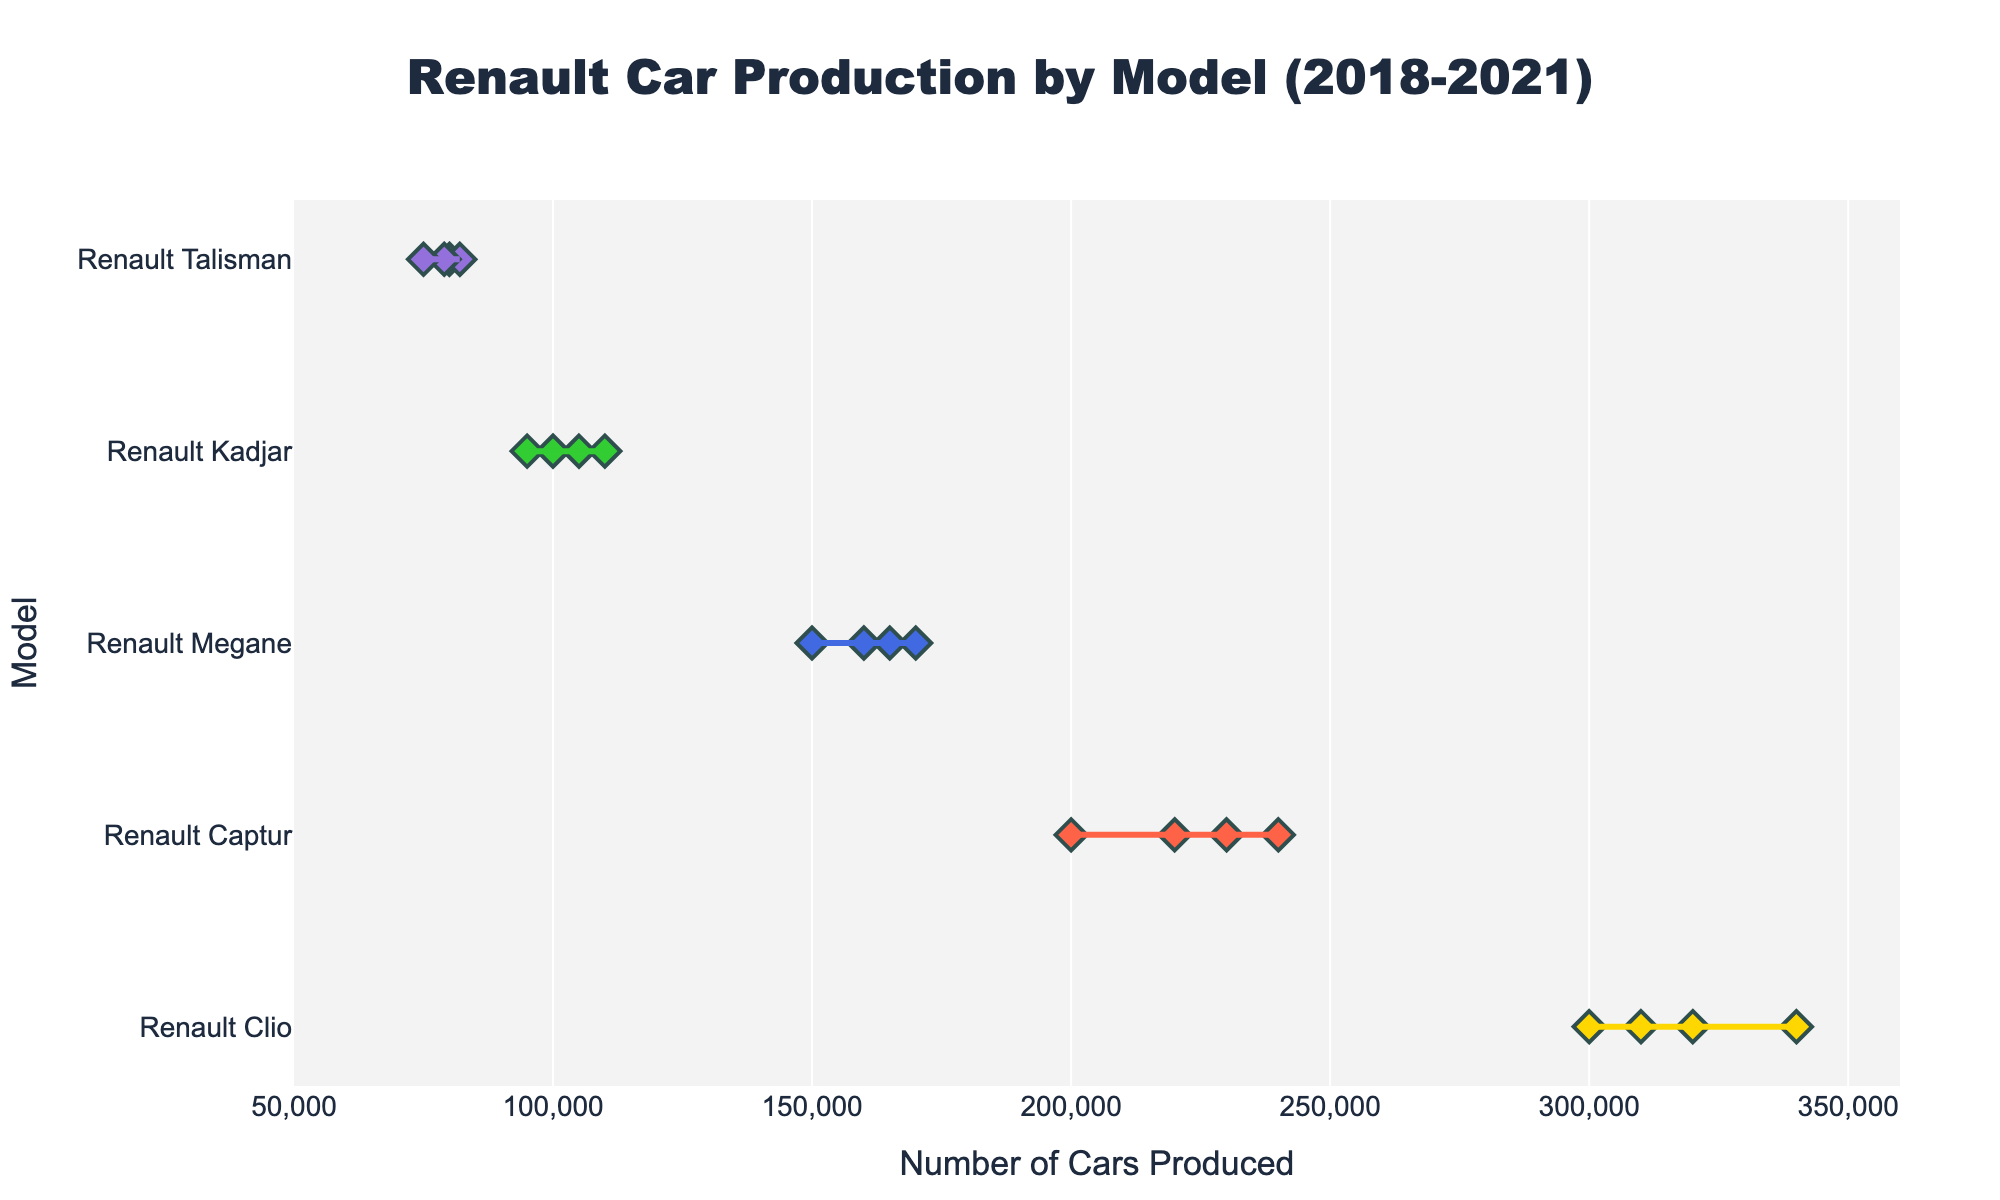What's the title of the figure? The title is usually displayed at the top of the figure. Here, it reads "Renault Car Production by Model (2018-2021)"
Answer: Renault Car Production by Model (2018-2021) Which model had the highest number of cars produced in a single year? By looking at the x-axis, the model Renault Clio in 2020 shows the point farthest to the right on the x-axis, indicating the highest single-year production of 340,000 cars.
Answer: Renault Clio What is the range of cars produced for the Renault Captur? The range is found by subtracting the minimum number of cars produced from the maximum. For Renault Captur, the maximum is 240,000 (2020) and the minimum is 200,000 (2018). The range is 240,000 - 200,000 = 40,000.
Answer: 40,000 How many unique models are shown in the figure? The y-axis lists each unique model name. There are Renault Clio, Renault Captur, Renault Megane, Renault Kadjar, and Renault Talisman, which totals to five.
Answer: 5 Which model had the least number of cars produced in 2021? By looking at the x-axis for the year 2021 and comparing the points, Renault Talisman shows the lowest value of 75,000 cars produced.
Answer: Renault Talisman What was the production trend for Renault Megane from 2018 to 2021? By tracing the points for Renault Megane from 2018 to 2021, the values are increasing slightly each year: 150,000 (2018), 160,000 (2019), 170,000 (2020), and slightly declining to 165,000 (2021). The overall trend shows a general increase except for a small drop in 2021.
Answer: Generally increasing How does the production range of Renault Kadjar compare to Renault Talisman? The range for a model is from its minimum to the maximum number of cars produced over the years. Renault Kadjar ranges from 95,000 to 110,000, which is a range of 15,000. Renault Talisman ranges from 75,000 to 82,000, which is a range of 7,000. The range for Renault Kadjar is larger.
Answer: Kadjar > Talisman What is the average number of cars produced per year for Renault Clio? The total number of cars produced by Renault Clio over the years is 300,000 + 320,000 + 340,000 + 310,000 = 1,270,000. Dividing by the 4 years, the average is 1,270,000 / 4 = 317,500.
Answer: 317,500 Which model shows the least variability in production over the years? Variability is the difference between the maximum and minimum values. Renault Talisman ranges from 75,000 to 82,000 (7,000 cars difference), whereas other models have larger ranges. So, Renault Talisman shows the least variability.
Answer: Renault Talisman 